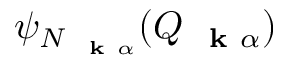Convert formula to latex. <formula><loc_0><loc_0><loc_500><loc_500>\psi _ { N _ { k \alpha } } ( Q _ { k \alpha } )</formula> 